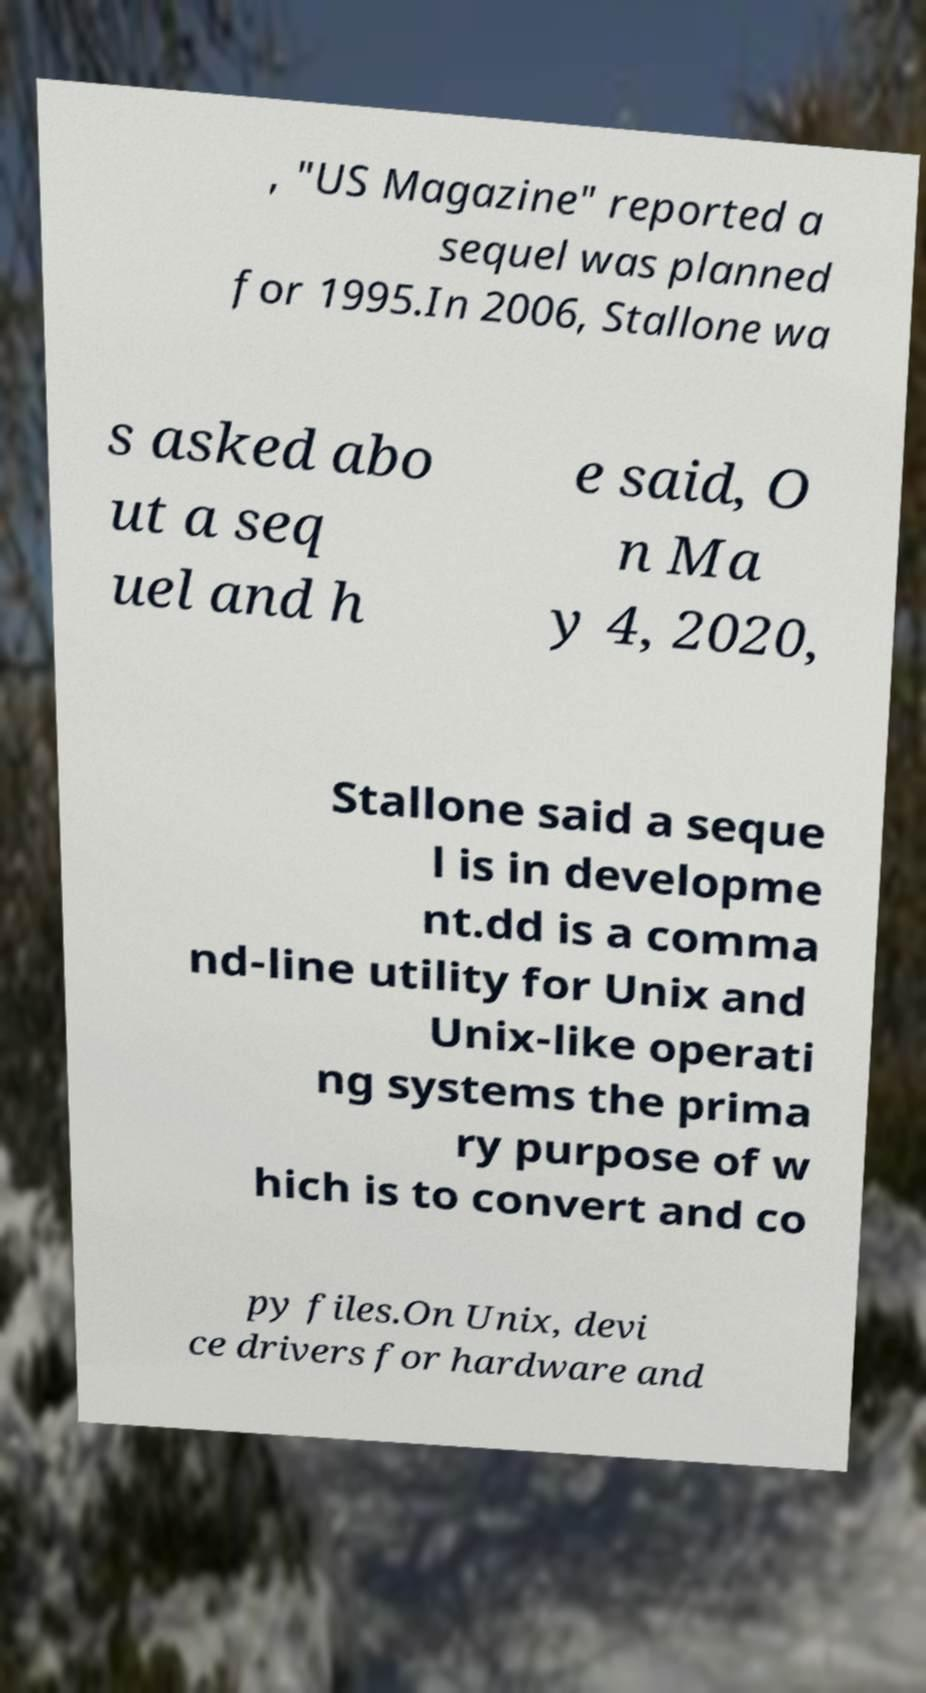Could you assist in decoding the text presented in this image and type it out clearly? , "US Magazine" reported a sequel was planned for 1995.In 2006, Stallone wa s asked abo ut a seq uel and h e said, O n Ma y 4, 2020, Stallone said a seque l is in developme nt.dd is a comma nd-line utility for Unix and Unix-like operati ng systems the prima ry purpose of w hich is to convert and co py files.On Unix, devi ce drivers for hardware and 